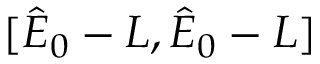<formula> <loc_0><loc_0><loc_500><loc_500>[ \hat { E } _ { 0 } - L , \hat { E } _ { 0 } - L ]</formula> 